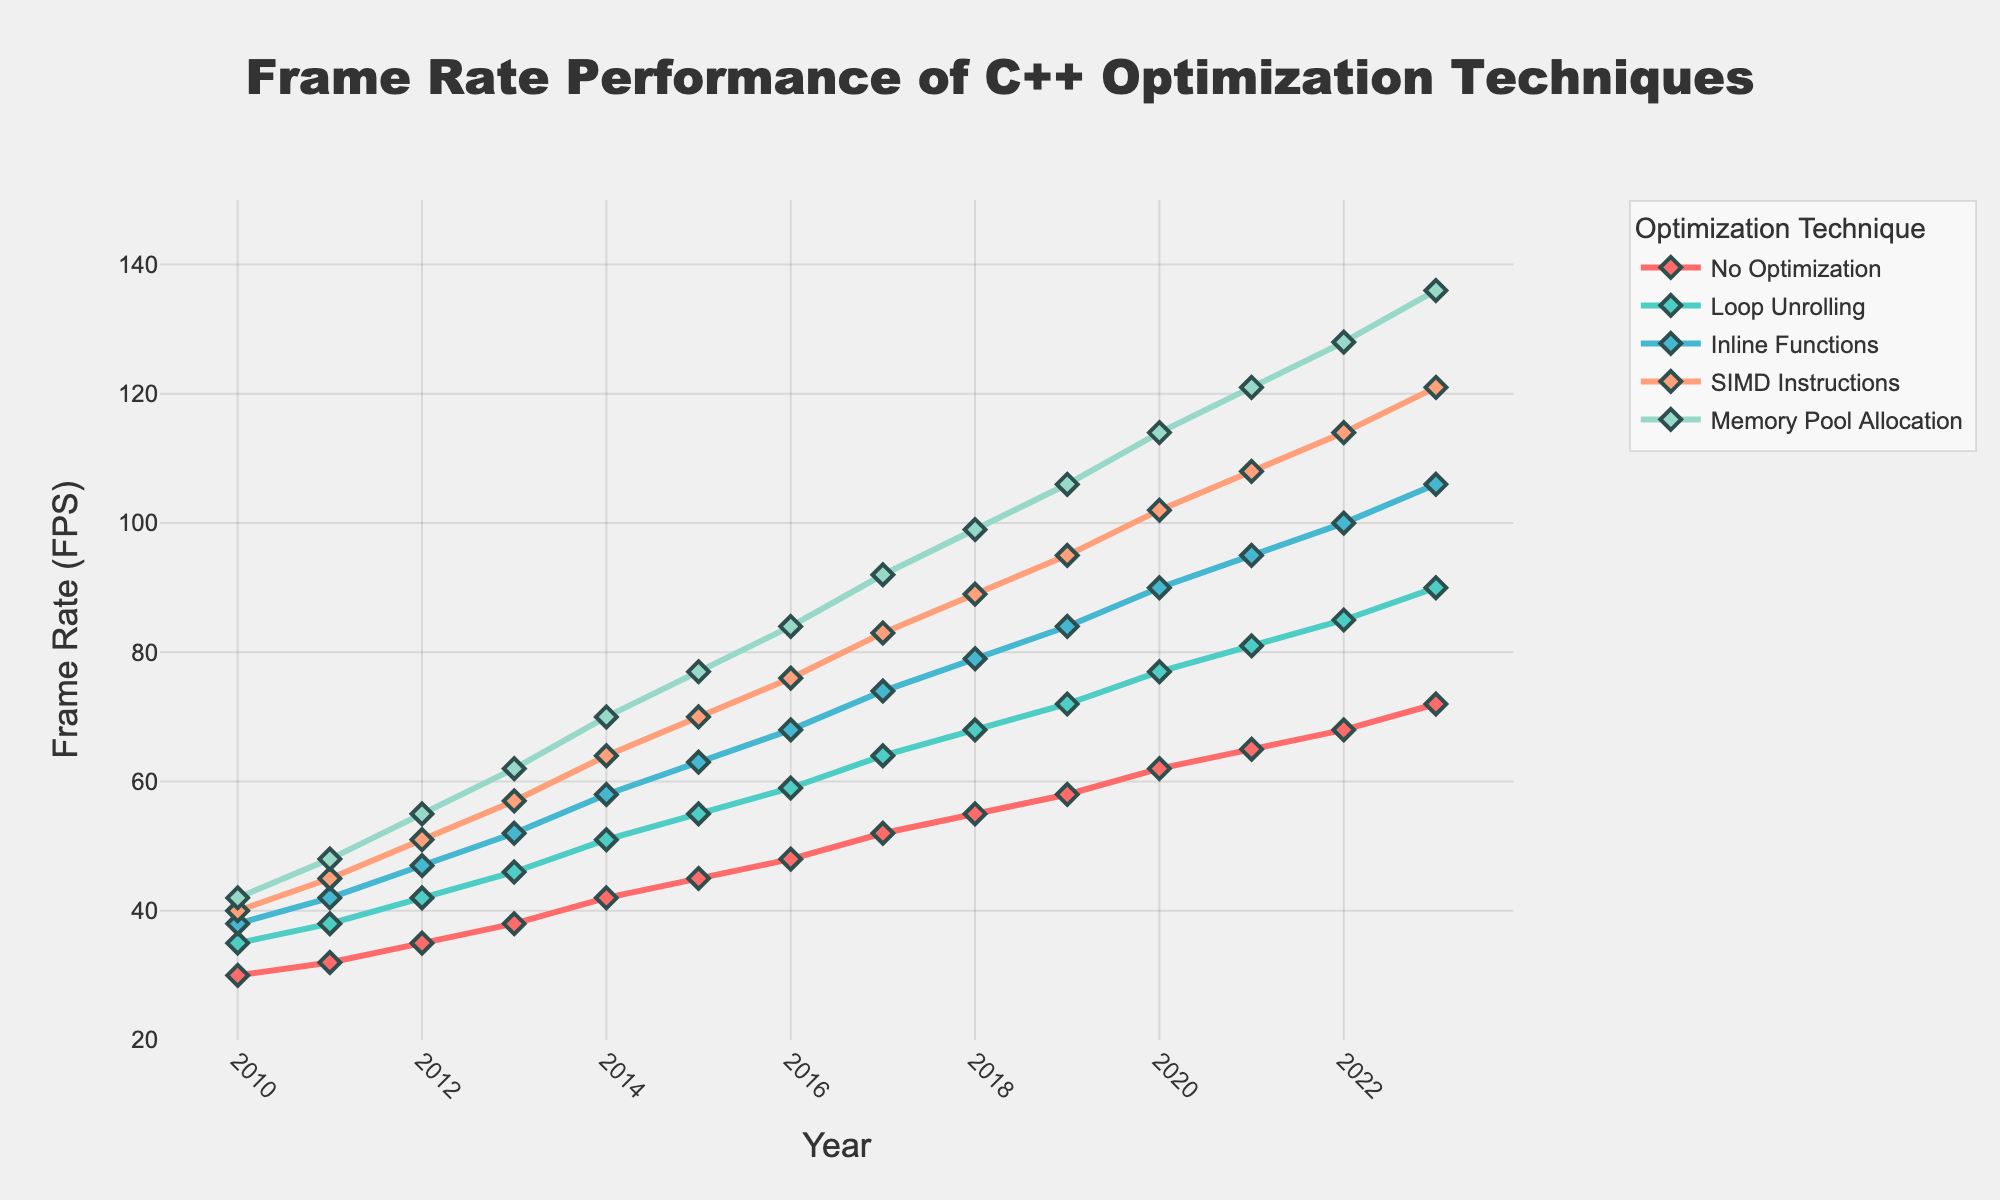What year did the 'Memory Pool Allocation' technique surpass the 100 FPS mark? Check the intersection of the 'Memory Pool Allocation' line with the 100 FPS line on the Y-axis. This occurs between 2019 and 2020.
Answer: 2020 Which optimization technique showed the least improvement in frame rate performance between 2010 and 2023? Calculate the difference in frame rate from 2010 to 2023 for each technique. 'No Optimization' goes from 30 FPS to 72 FPS, a 42 FPS improvement; other techniques have greater improvements.
Answer: No Optimization What was the frame rate difference between 'Inline Functions' and 'SIMD Instructions' in 2015? Find the frame rates for 'Inline Functions' (63 FPS) and 'SIMD Instructions' (70 FPS) in 2015, then subtract one from the other.
Answer: 7 FPS Which optimization technique had the highest frame rate performance in 2017? Check the frame rates for each technique in 2017. 'Memory Pool Allocation' has the highest frame rate at 92 FPS.
Answer: Memory Pool Allocation What is the average frame rate of 'Loop Unrolling' from 2020 to 2023? Add the frame rates for 'Loop Unrolling' from 2020 to 2023 (77 + 81 + 85 + 90) and divide by the number of years (4).
Answer: 83.25 FPS In which year did 'Loop Unrolling' surpass 'No Optimization' in terms of frame rate performance? Check where the 'Loop Unrolling' line intersects and moves above the 'No Optimization' line on the graph. This happens between 2010 and 2011.
Answer: 2011 By how much did the frame rate of 'SIMD Instructions' increase from 2011 to 2018? Subtract the frame rate in 2011 (45 FPS) from the frame rate in 2018 (89 FPS).
Answer: 44 FPS What is the visual difference in the color of the lines representing 'No Optimization' and 'SIMD Instructions'? 'No Optimization' is represented by the red line, and 'SIMD Instructions' is represented by the light orange line.
Answer: Red vs Light Orange Which optimization technique had the most consistent year-over-year frame rate increase? Look at the steadiness of the slopes; 'No Optimization' has a more consistent and gradual increase compared to the others.
Answer: No Optimization 